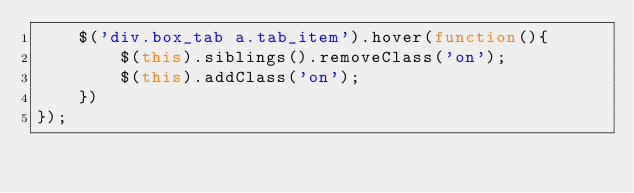Convert code to text. <code><loc_0><loc_0><loc_500><loc_500><_JavaScript_>	$('div.box_tab a.tab_item').hover(function(){
		$(this).siblings().removeClass('on');
		$(this).addClass('on');
	})
});
</code> 